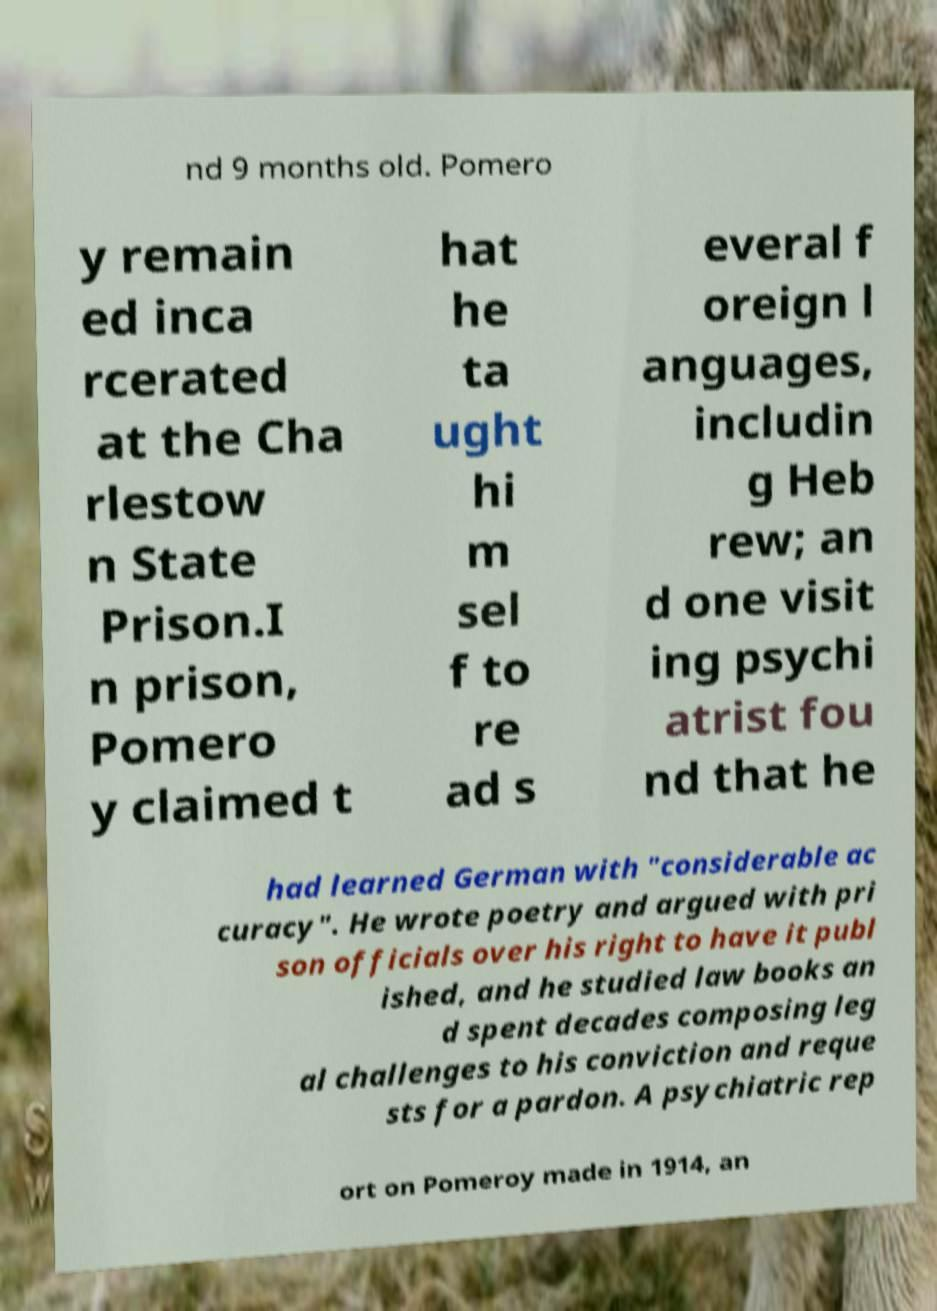There's text embedded in this image that I need extracted. Can you transcribe it verbatim? nd 9 months old. Pomero y remain ed inca rcerated at the Cha rlestow n State Prison.I n prison, Pomero y claimed t hat he ta ught hi m sel f to re ad s everal f oreign l anguages, includin g Heb rew; an d one visit ing psychi atrist fou nd that he had learned German with "considerable ac curacy". He wrote poetry and argued with pri son officials over his right to have it publ ished, and he studied law books an d spent decades composing leg al challenges to his conviction and reque sts for a pardon. A psychiatric rep ort on Pomeroy made in 1914, an 